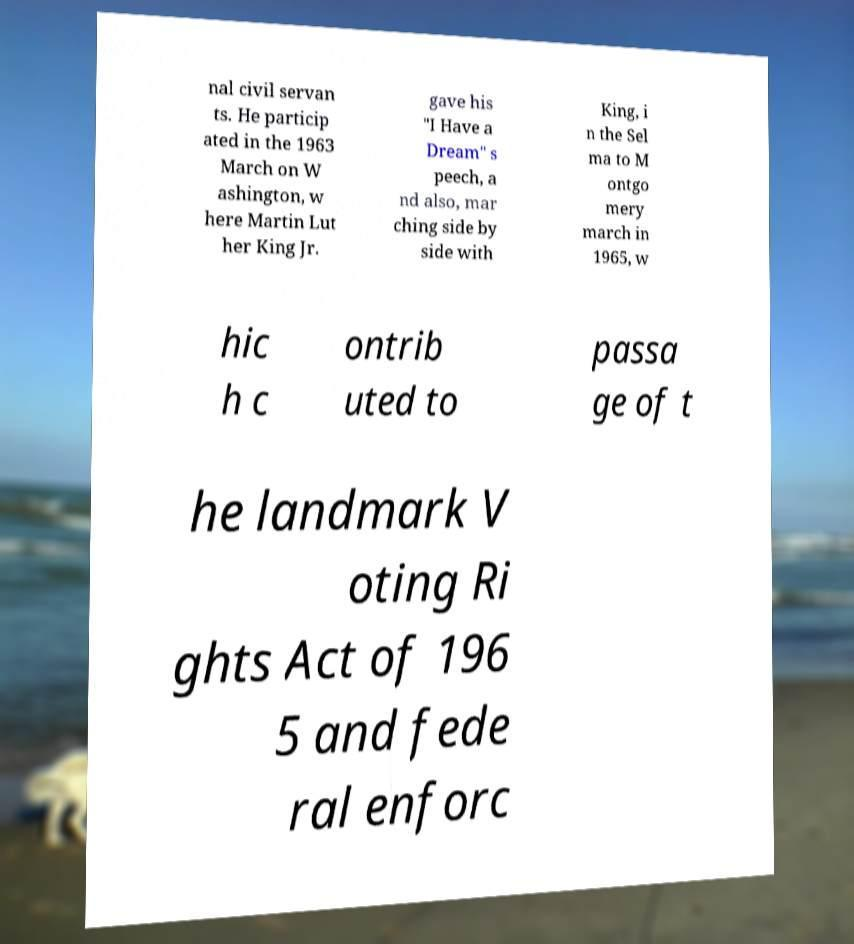Can you accurately transcribe the text from the provided image for me? nal civil servan ts. He particip ated in the 1963 March on W ashington, w here Martin Lut her King Jr. gave his "I Have a Dream" s peech, a nd also, mar ching side by side with King, i n the Sel ma to M ontgo mery march in 1965, w hic h c ontrib uted to passa ge of t he landmark V oting Ri ghts Act of 196 5 and fede ral enforc 